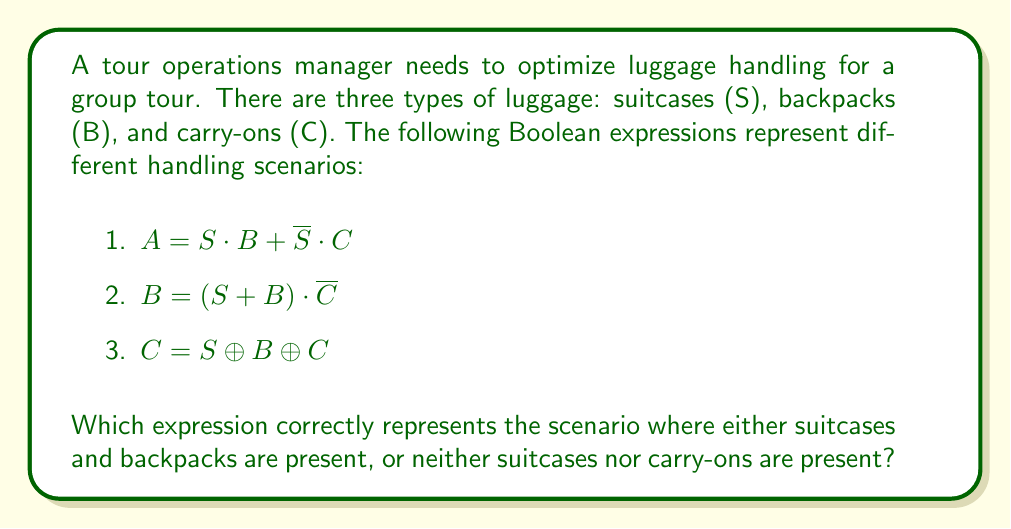Could you help me with this problem? Let's analyze each expression:

1. $A = S \cdot B + \overline{S} \cdot C$
   This expression is true when:
   - Suitcases AND backpacks are present, OR
   - Suitcases are NOT present AND carry-ons are present
   This does not match our target scenario.

2. $B = (S + B) \cdot \overline{C}$
   This expression is true when:
   - (Suitcases OR backpacks are present) AND carry-ons are NOT present
   This also does not match our target scenario.

3. $C = S \oplus B \oplus C$
   This expression uses XOR operations, which is true when an odd number of variables are true. This does not represent our target scenario.

The correct expression for our scenario should be:

$$(S \cdot B) + (\overline{S} \cdot \overline{C})$$

This expression is true when:
- Suitcases AND backpacks are present, OR
- Neither suitcases NOR carry-ons are present

We can verify this using a truth table:

| S | B | C | $(S \cdot B) + (\overline{S} \cdot \overline{C})$ |
|---|---|---|--------------------------------------------------|
| 0 | 0 | 0 | 1 |
| 0 | 0 | 1 | 0 |
| 0 | 1 | 0 | 1 |
| 0 | 1 | 1 | 0 |
| 1 | 0 | 0 | 0 |
| 1 | 0 | 1 | 0 |
| 1 | 1 | 0 | 1 |
| 1 | 1 | 1 | 1 |

This truth table confirms that our expression correctly represents the desired scenario.
Answer: $(S \cdot B) + (\overline{S} \cdot \overline{C})$ 